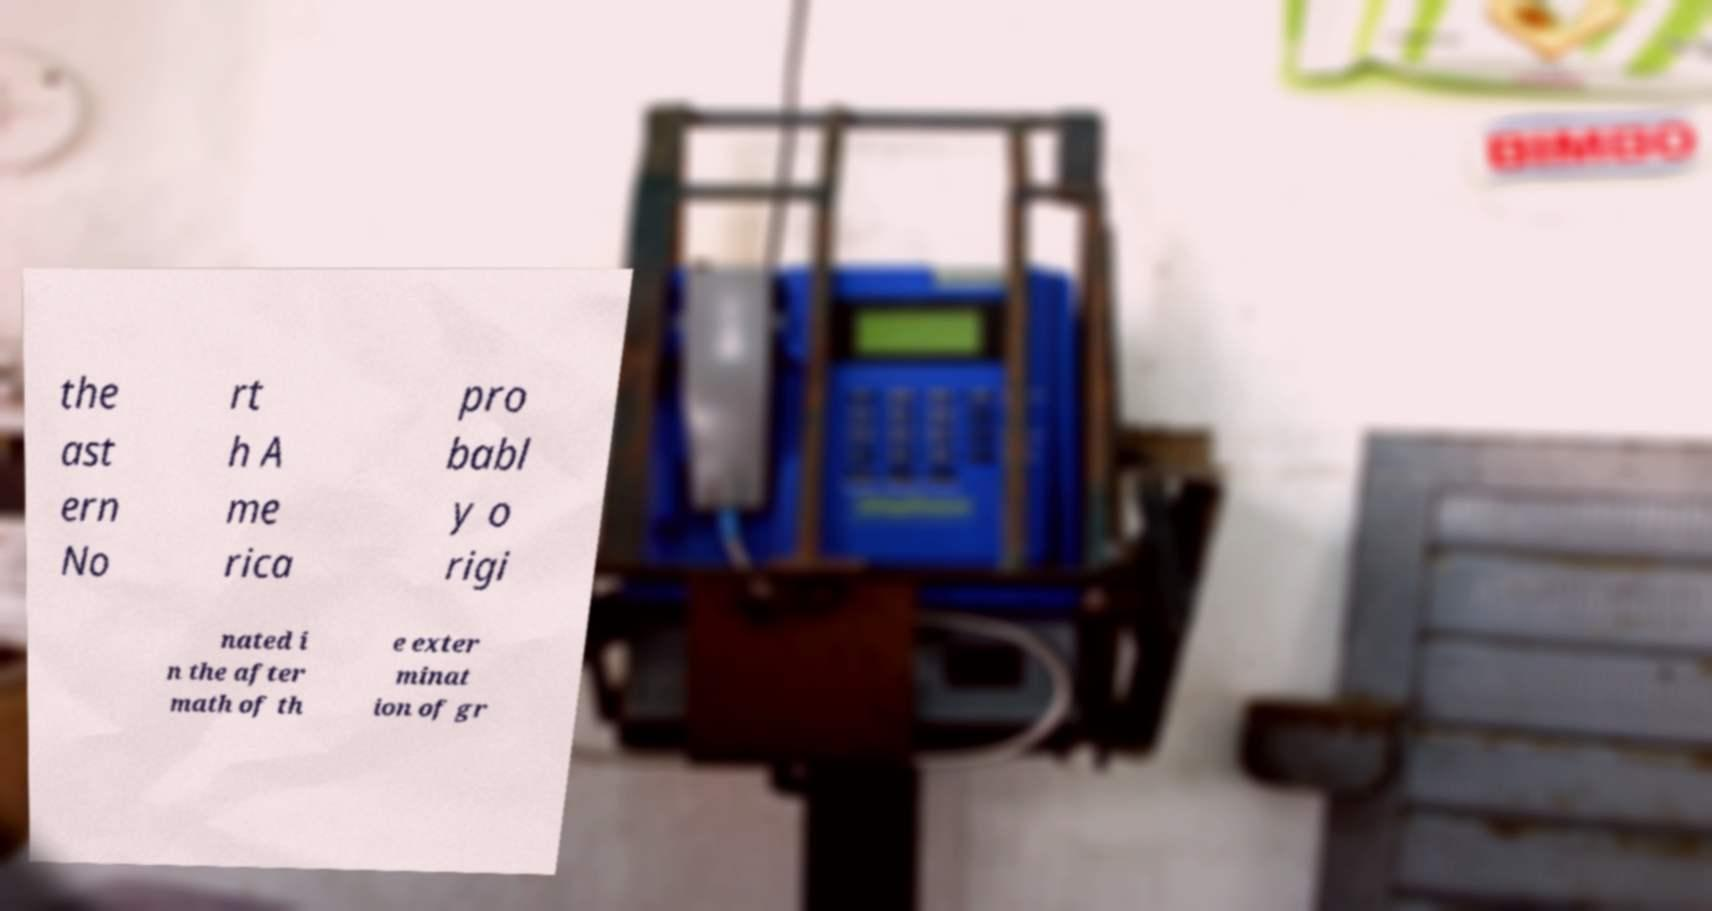What messages or text are displayed in this image? I need them in a readable, typed format. the ast ern No rt h A me rica pro babl y o rigi nated i n the after math of th e exter minat ion of gr 